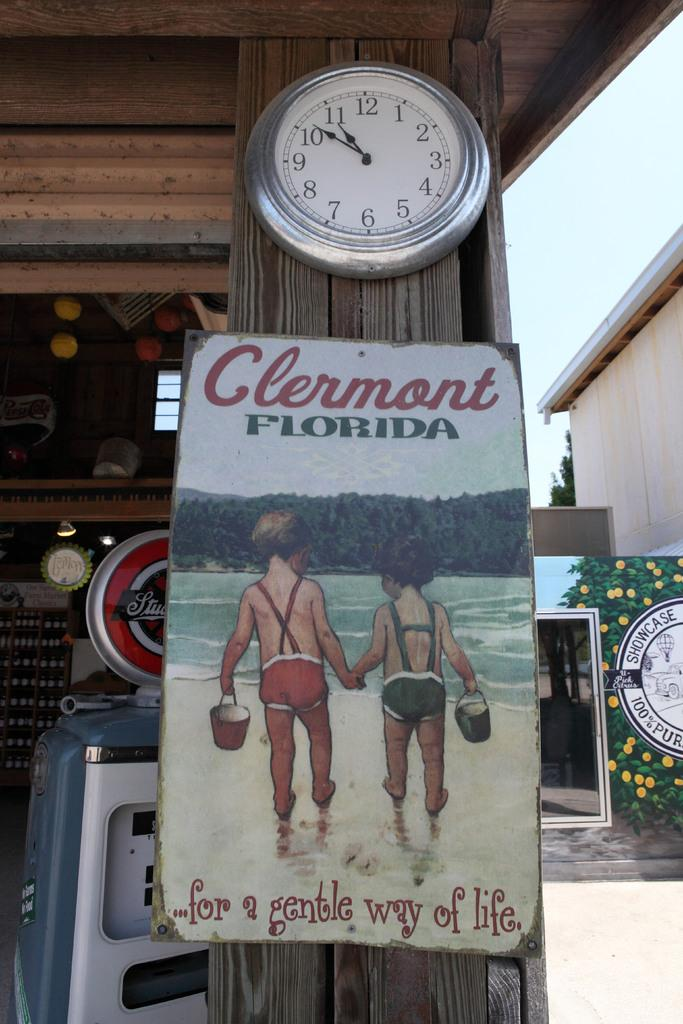<image>
Share a concise interpretation of the image provided. Poster on a wooden pole which says Clermont Florida on it. 